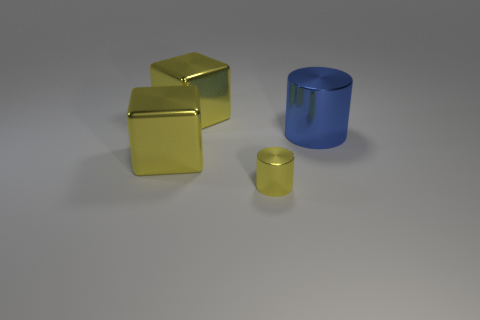The large object on the right side of the yellow cylinder has what shape?
Offer a very short reply. Cylinder. What is the color of the small shiny object?
Provide a short and direct response. Yellow. There is a blue cylinder; does it have the same size as the cylinder on the left side of the large blue cylinder?
Keep it short and to the point. No. What number of metallic objects are either blue things or large blocks?
Offer a very short reply. 3. There is a tiny metal thing; is it the same color as the big metallic thing in front of the blue metallic cylinder?
Keep it short and to the point. Yes. What size is the yellow metallic cube that is to the right of the yellow cube that is in front of the big thing that is right of the small metallic cylinder?
Offer a terse response. Large. There is a metallic object that is on the right side of the tiny object; is it the same shape as the tiny object in front of the blue metal thing?
Offer a very short reply. Yes. How many blocks are small yellow metal objects or yellow objects?
Make the answer very short. 2. How many other objects are there of the same size as the blue shiny thing?
Give a very brief answer. 2. Are there more yellow blocks that are in front of the blue object than tiny purple matte balls?
Give a very brief answer. Yes. 